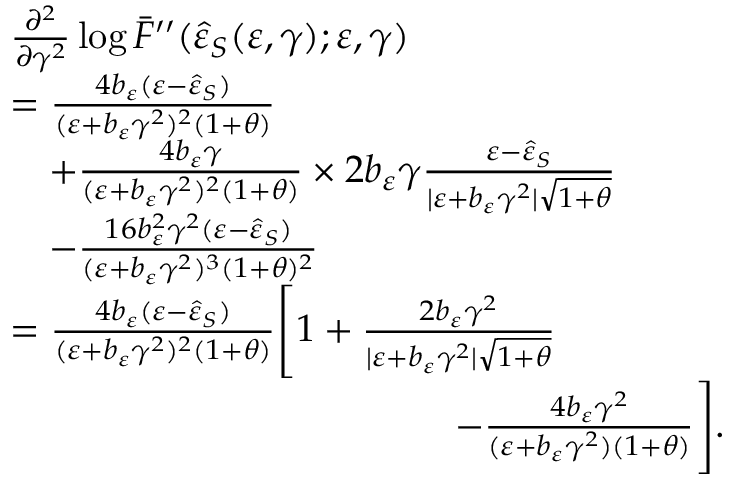<formula> <loc_0><loc_0><loc_500><loc_500>\begin{array} { r l } & { \frac { \partial ^ { 2 } } { \partial \gamma ^ { 2 } } \log { \bar { F } ^ { \prime \prime } ( \hat { \varepsilon } _ { S } ( \varepsilon , \gamma ) ; \varepsilon , \gamma ) } } \\ & { = \frac { 4 b _ { \varepsilon } ( \varepsilon - \hat { \varepsilon } _ { S } ) } { ( \varepsilon + b _ { \varepsilon } \gamma ^ { 2 } ) ^ { 2 } ( 1 + \theta ) } } \\ & { \quad + \frac { 4 b _ { \varepsilon } \gamma } { ( \varepsilon + b _ { \varepsilon } \gamma ^ { 2 } ) ^ { 2 } ( 1 + \theta ) } \times 2 b _ { \varepsilon } \gamma \frac { \varepsilon - \hat { \varepsilon } _ { S } } { | \varepsilon + b _ { \varepsilon } \gamma ^ { 2 } | \sqrt { 1 + \theta } } } \\ & { \quad - \frac { 1 6 b _ { \varepsilon } ^ { 2 } \gamma ^ { 2 } ( \varepsilon - \hat { \varepsilon } _ { S } ) } { ( \varepsilon + b _ { \varepsilon } \gamma ^ { 2 } ) ^ { 3 } ( 1 + \theta ) ^ { 2 } } } \\ & { = \frac { 4 b _ { \varepsilon } ( \varepsilon - \hat { \varepsilon } _ { S } ) } { ( \varepsilon + b _ { \varepsilon } \gamma ^ { 2 } ) ^ { 2 } ( 1 + \theta ) } \left [ 1 + \frac { 2 b _ { \varepsilon } \gamma ^ { 2 } } { | \varepsilon + b _ { \varepsilon } \gamma ^ { 2 } | \sqrt { 1 + \theta } } } \\ & { \quad \, - \frac { 4 b _ { \varepsilon } \gamma ^ { 2 } } { ( \varepsilon + b _ { \varepsilon } \gamma ^ { 2 } ) ( 1 + \theta ) } \right ] . } \end{array}</formula> 